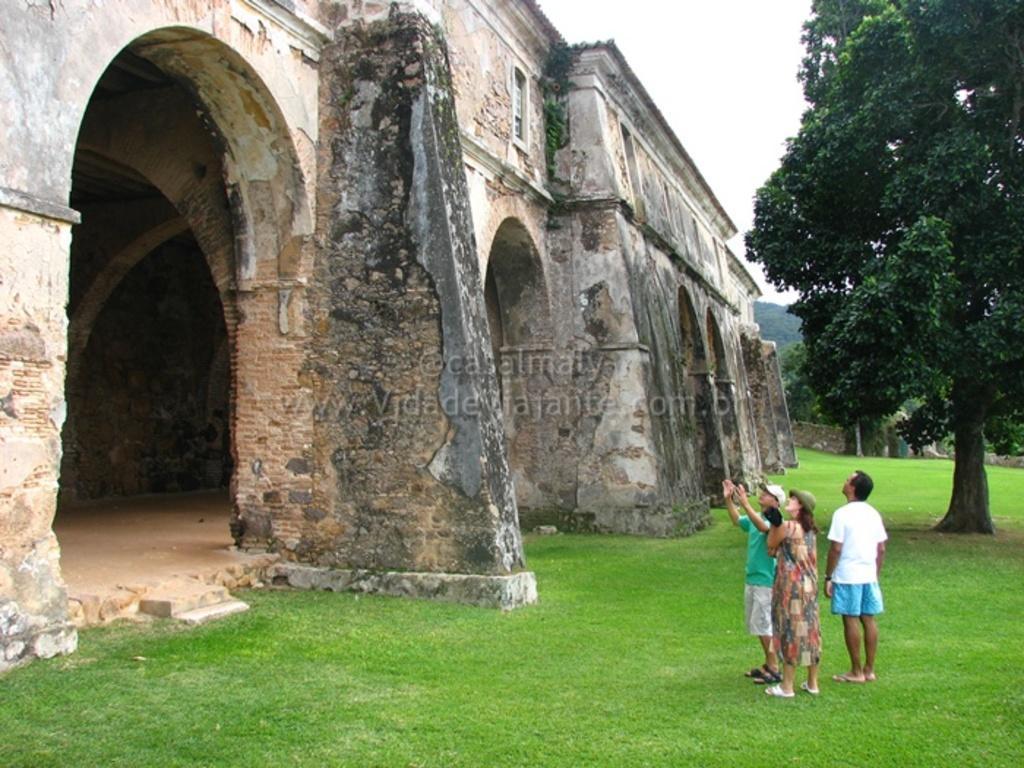In one or two sentences, can you explain what this image depicts? In this image there is a grass land on that land there are three persons, in front of them there is a monument, in the background there are trees. 